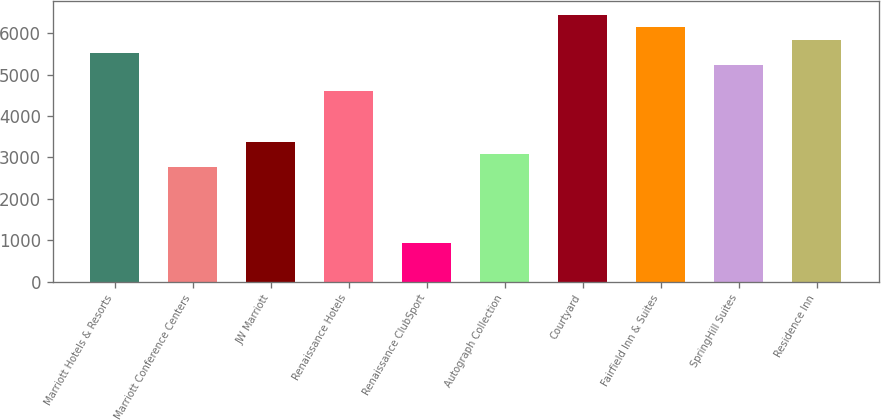Convert chart. <chart><loc_0><loc_0><loc_500><loc_500><bar_chart><fcel>Marriott Hotels & Resorts<fcel>Marriott Conference Centers<fcel>JW Marriott<fcel>Renaissance Hotels<fcel>Renaissance ClubSport<fcel>Autograph Collection<fcel>Courtyard<fcel>Fairfield Inn & Suites<fcel>SpringHill Suites<fcel>Residence Inn<nl><fcel>5532.68<fcel>2766.71<fcel>3381.37<fcel>4610.69<fcel>922.73<fcel>3074.04<fcel>6454.67<fcel>6147.34<fcel>5225.35<fcel>5840.01<nl></chart> 